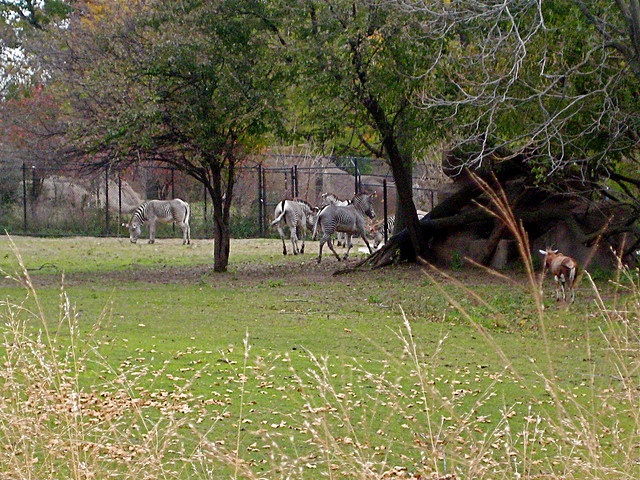Describe the objects in this image and their specific colors. I can see zebra in lavender, gray, black, and darkgray tones, zebra in lavender, gray, darkgray, and lightgray tones, zebra in lavender, gray, darkgray, black, and lightgray tones, zebra in lavender, gray, darkgray, black, and lightgray tones, and zebra in lavender, darkgray, gray, and lightgray tones in this image. 